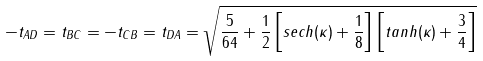<formula> <loc_0><loc_0><loc_500><loc_500>- t _ { A D } = t _ { B C } = - t _ { C B } = t _ { D A } = \sqrt { \frac { 5 } { 6 4 } + \frac { 1 } { 2 } \left [ s e c h ( \kappa ) + \frac { 1 } { 8 } \right ] \left [ t a n h ( \kappa ) + \frac { 3 } { 4 } \right ] }</formula> 